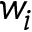<formula> <loc_0><loc_0><loc_500><loc_500>w _ { i }</formula> 